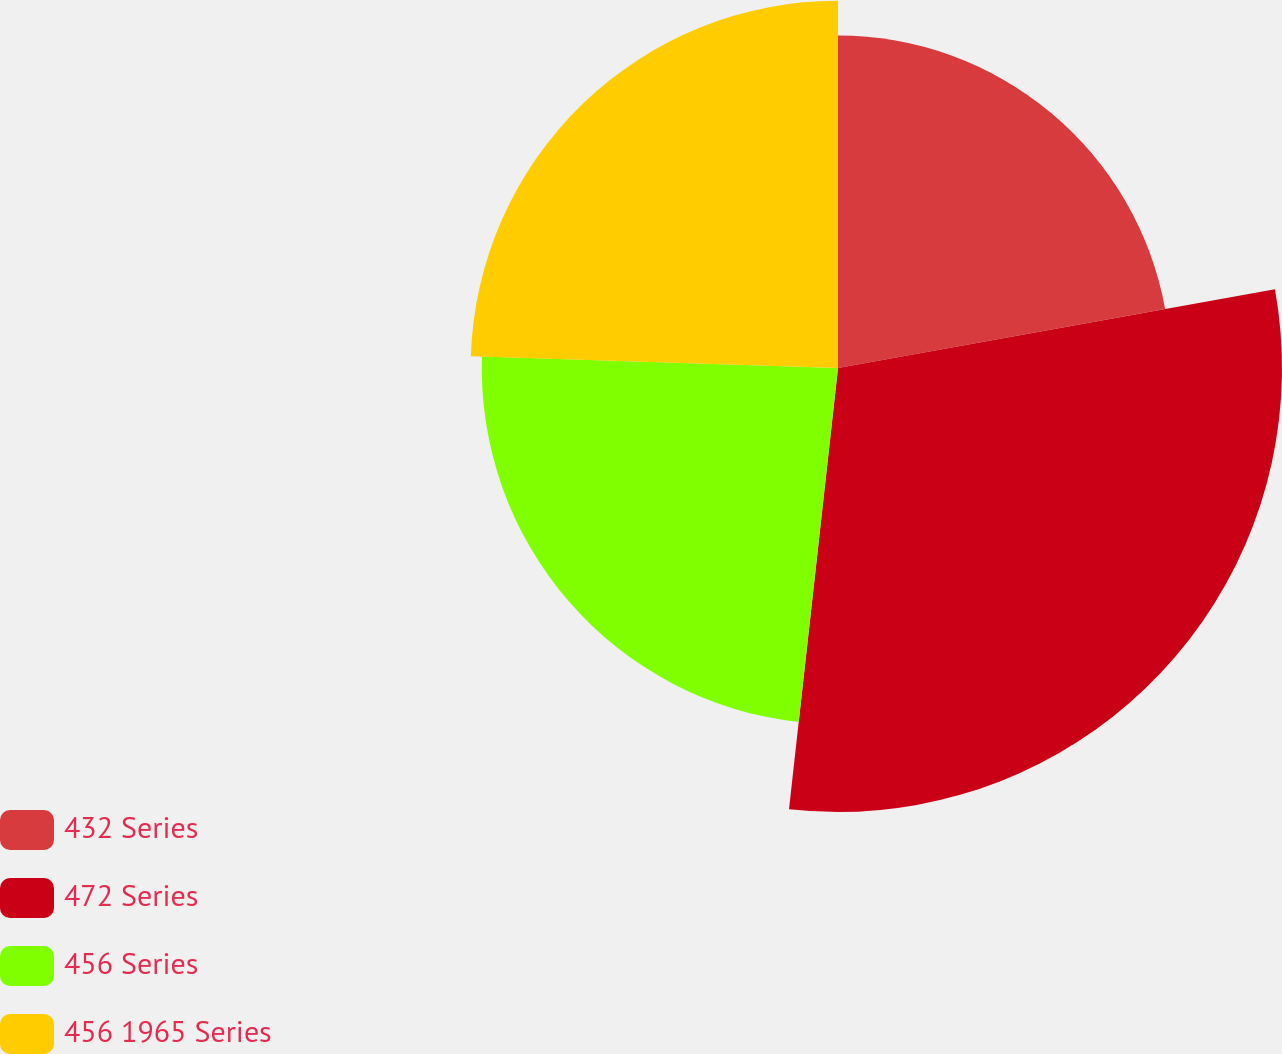Convert chart. <chart><loc_0><loc_0><loc_500><loc_500><pie_chart><fcel>432 Series<fcel>472 Series<fcel>456 Series<fcel>456 1965 Series<nl><fcel>22.16%<fcel>29.6%<fcel>23.75%<fcel>24.49%<nl></chart> 